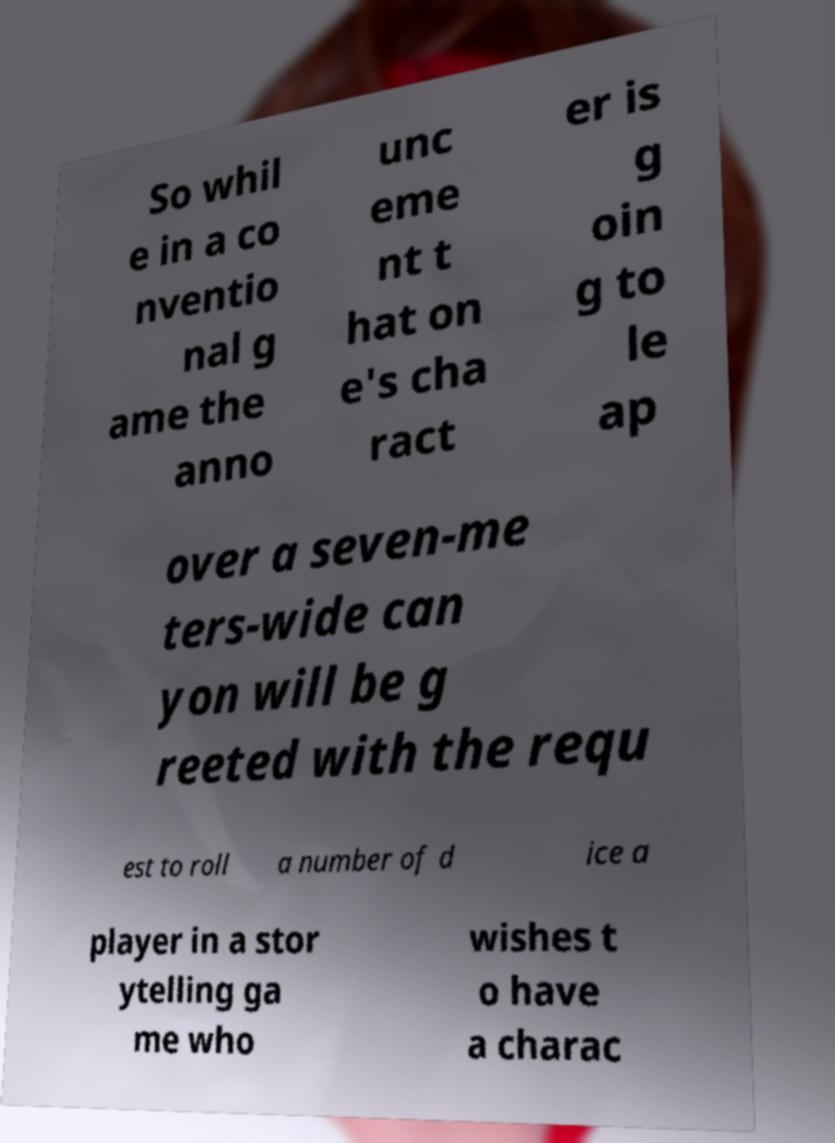Could you extract and type out the text from this image? So whil e in a co nventio nal g ame the anno unc eme nt t hat on e's cha ract er is g oin g to le ap over a seven-me ters-wide can yon will be g reeted with the requ est to roll a number of d ice a player in a stor ytelling ga me who wishes t o have a charac 